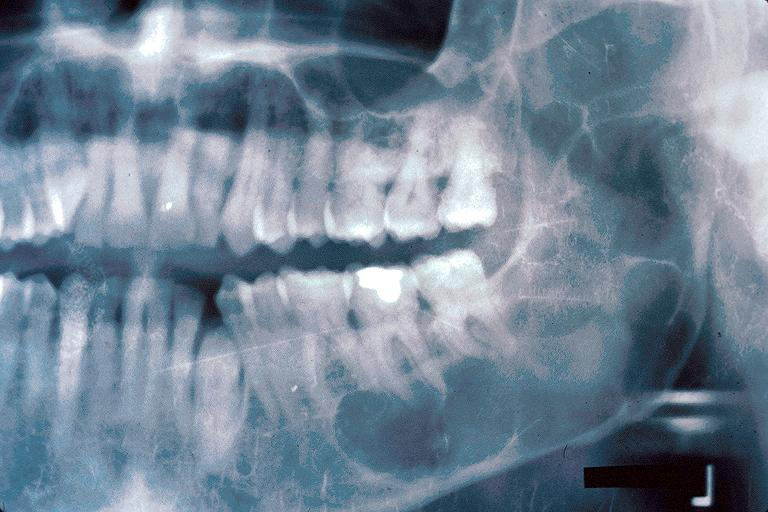s bilobed present?
Answer the question using a single word or phrase. No 